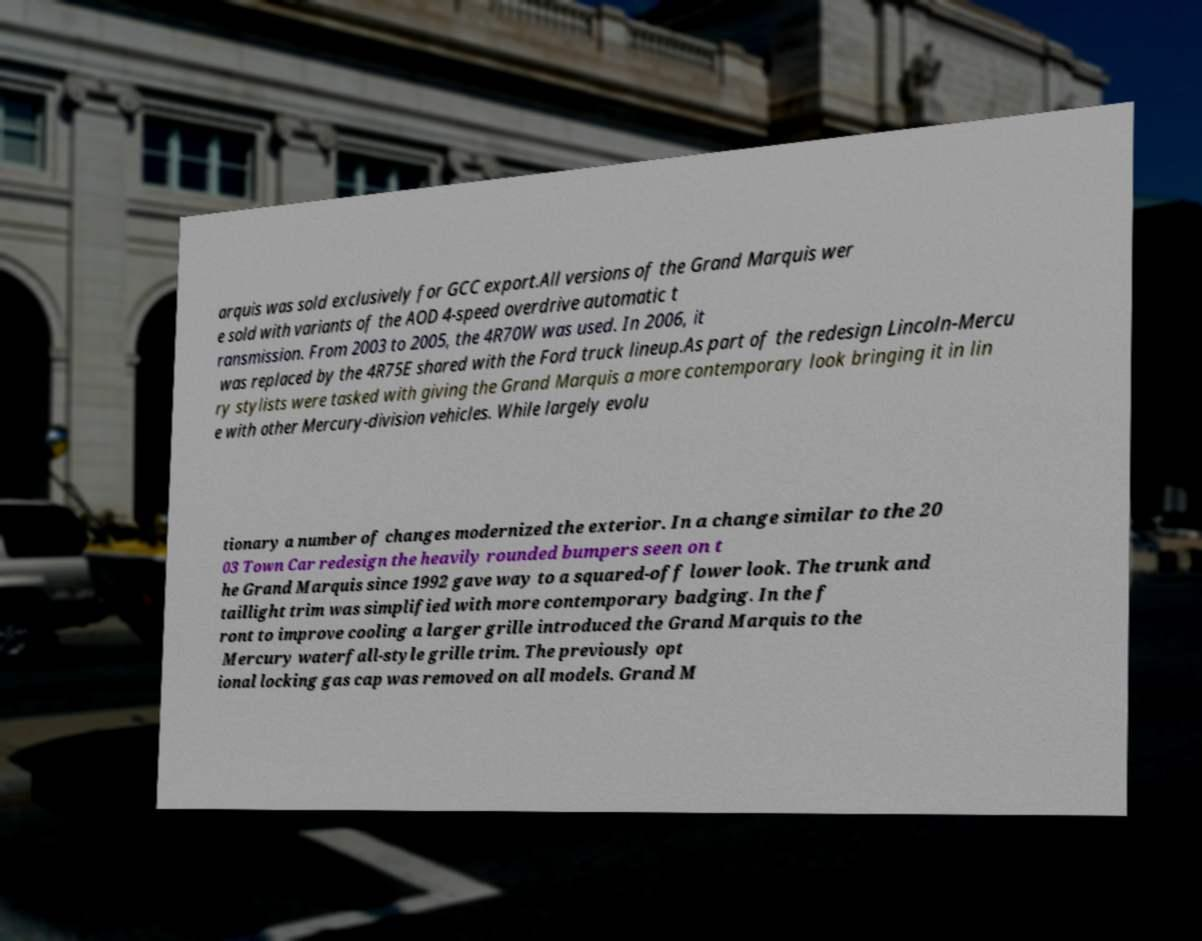Could you assist in decoding the text presented in this image and type it out clearly? arquis was sold exclusively for GCC export.All versions of the Grand Marquis wer e sold with variants of the AOD 4-speed overdrive automatic t ransmission. From 2003 to 2005, the 4R70W was used. In 2006, it was replaced by the 4R75E shared with the Ford truck lineup.As part of the redesign Lincoln-Mercu ry stylists were tasked with giving the Grand Marquis a more contemporary look bringing it in lin e with other Mercury-division vehicles. While largely evolu tionary a number of changes modernized the exterior. In a change similar to the 20 03 Town Car redesign the heavily rounded bumpers seen on t he Grand Marquis since 1992 gave way to a squared-off lower look. The trunk and taillight trim was simplified with more contemporary badging. In the f ront to improve cooling a larger grille introduced the Grand Marquis to the Mercury waterfall-style grille trim. The previously opt ional locking gas cap was removed on all models. Grand M 